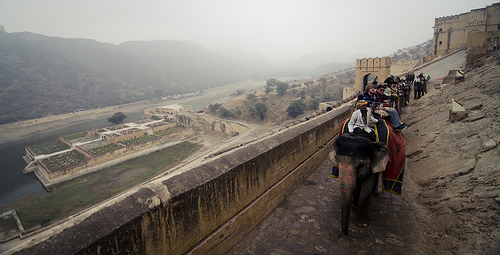Please provide a short description for this region: [0.75, 0.41, 0.78, 0.43]. In this specific bounding box, a man wearing sunglasses is observed, suggesting a bright day. His attire is casual, fitting for a tourist. 